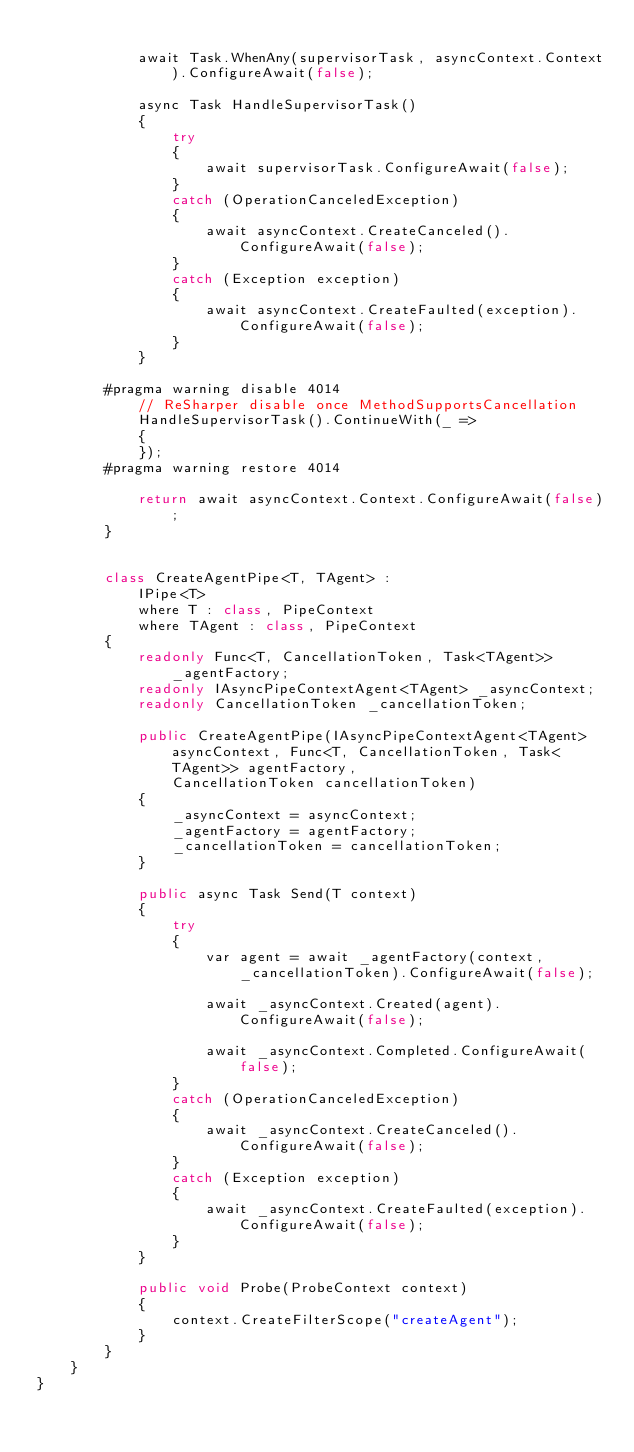Convert code to text. <code><loc_0><loc_0><loc_500><loc_500><_C#_>
            await Task.WhenAny(supervisorTask, asyncContext.Context).ConfigureAwait(false);

            async Task HandleSupervisorTask()
            {
                try
                {
                    await supervisorTask.ConfigureAwait(false);
                }
                catch (OperationCanceledException)
                {
                    await asyncContext.CreateCanceled().ConfigureAwait(false);
                }
                catch (Exception exception)
                {
                    await asyncContext.CreateFaulted(exception).ConfigureAwait(false);
                }
            }

        #pragma warning disable 4014
            // ReSharper disable once MethodSupportsCancellation
            HandleSupervisorTask().ContinueWith(_ =>
            {
            });
        #pragma warning restore 4014

            return await asyncContext.Context.ConfigureAwait(false);
        }


        class CreateAgentPipe<T, TAgent> :
            IPipe<T>
            where T : class, PipeContext
            where TAgent : class, PipeContext
        {
            readonly Func<T, CancellationToken, Task<TAgent>> _agentFactory;
            readonly IAsyncPipeContextAgent<TAgent> _asyncContext;
            readonly CancellationToken _cancellationToken;

            public CreateAgentPipe(IAsyncPipeContextAgent<TAgent> asyncContext, Func<T, CancellationToken, Task<TAgent>> agentFactory,
                CancellationToken cancellationToken)
            {
                _asyncContext = asyncContext;
                _agentFactory = agentFactory;
                _cancellationToken = cancellationToken;
            }

            public async Task Send(T context)
            {
                try
                {
                    var agent = await _agentFactory(context, _cancellationToken).ConfigureAwait(false);

                    await _asyncContext.Created(agent).ConfigureAwait(false);

                    await _asyncContext.Completed.ConfigureAwait(false);
                }
                catch (OperationCanceledException)
                {
                    await _asyncContext.CreateCanceled().ConfigureAwait(false);
                }
                catch (Exception exception)
                {
                    await _asyncContext.CreateFaulted(exception).ConfigureAwait(false);
                }
            }

            public void Probe(ProbeContext context)
            {
                context.CreateFilterScope("createAgent");
            }
        }
    }
}
</code> 